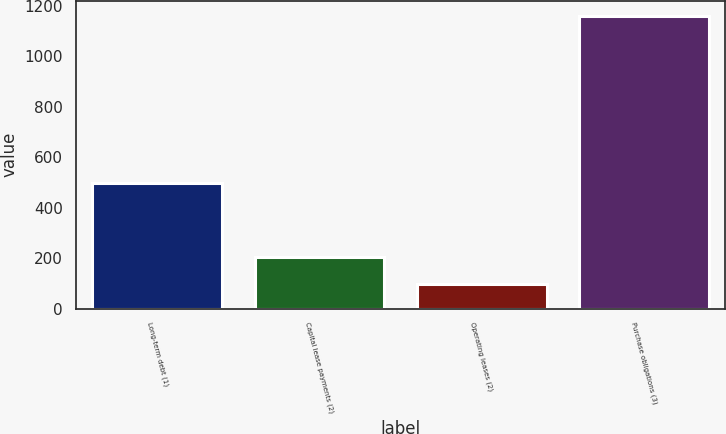Convert chart to OTSL. <chart><loc_0><loc_0><loc_500><loc_500><bar_chart><fcel>Long-term debt (1)<fcel>Capital lease payments (2)<fcel>Operating leases (2)<fcel>Purchase obligations (3)<nl><fcel>496<fcel>205.1<fcel>99<fcel>1160<nl></chart> 